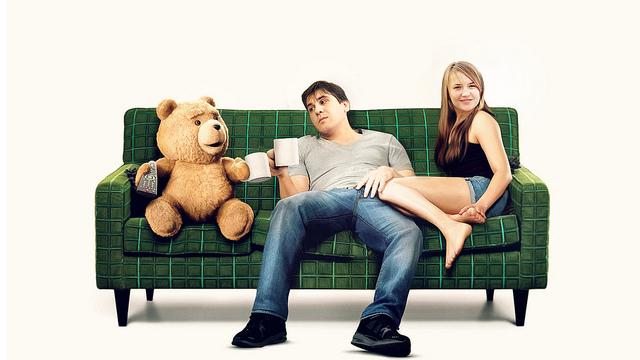How many cups are in this picture?
Keep it brief. 2. Are these people family?
Write a very short answer. No. What color is the couch?
Quick response, please. Green. 